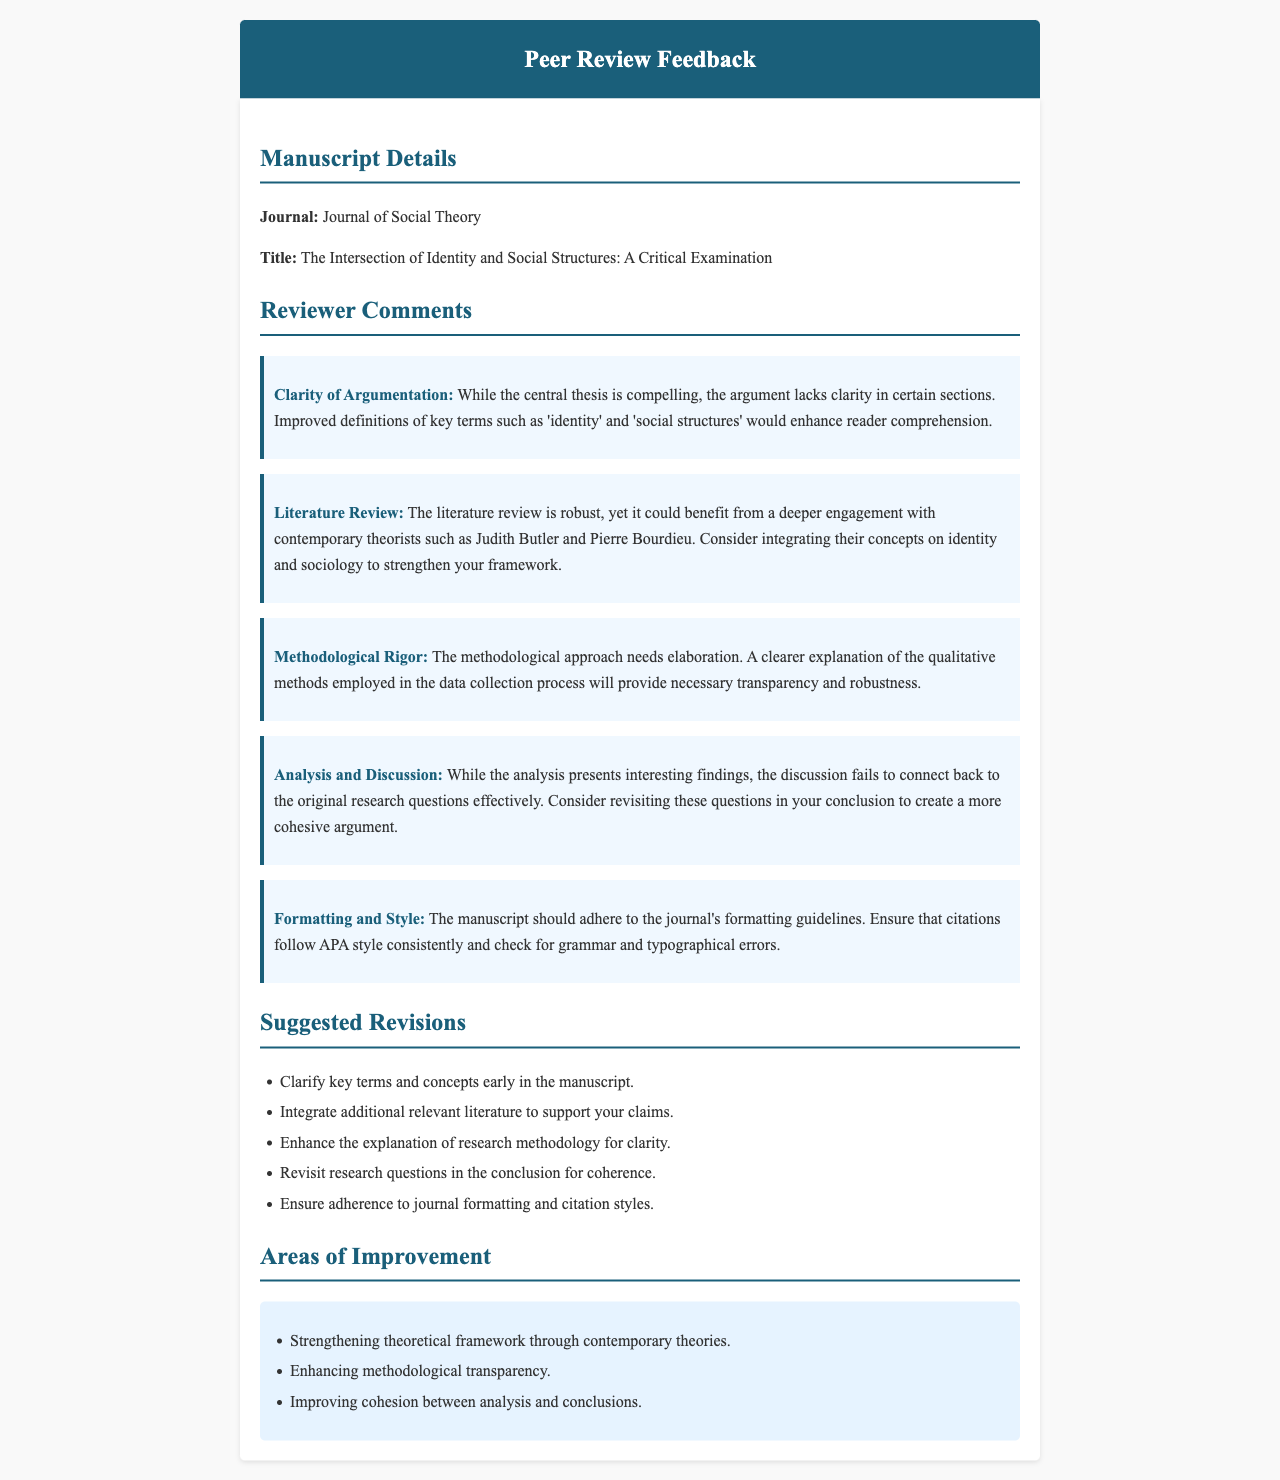What is the title of the manuscript? The title of the manuscript is presented in the document under the Manuscript Details section.
Answer: The Intersection of Identity and Social Structures: A Critical Examination Who is suggested to be integrated into the literature review? The feedback mentions specific contemporary theorists whose work could enhance the literature review.
Answer: Judith Butler and Pierre Bourdieu What aspect of the argumentation needs improvement? The document outlines what specific element within the argumentation should be clarified.
Answer: Clarity in certain sections What is a major area for improvement in the methodology? The reviewer comments detail the need for a specific enhancement in the methodological section.
Answer: Elaboration on qualitative methods What formatting style should be followed? The document specifies a citation style that should be adhered to in the manuscript.
Answer: APA style How many suggested revisions are listed? The feedback section provides a count of distinct suggestions for revisions in the manuscript.
Answer: Five What does the analysis fail to connect back to? This question seeks to identify what the discussion lacks in relation to its content.
Answer: Original research questions What is the primary journal for this manuscript submission? The name of the journal is included in the manuscript details.
Answer: Journal of Social Theory 